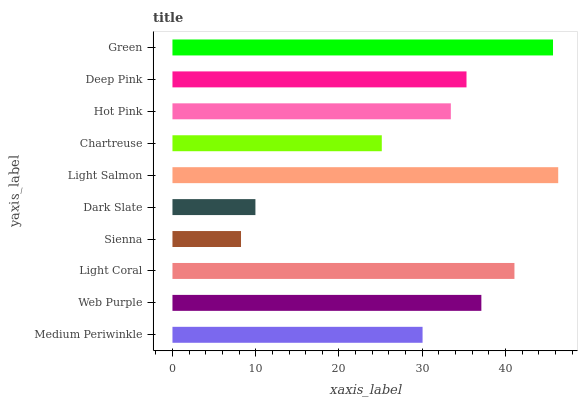Is Sienna the minimum?
Answer yes or no. Yes. Is Light Salmon the maximum?
Answer yes or no. Yes. Is Web Purple the minimum?
Answer yes or no. No. Is Web Purple the maximum?
Answer yes or no. No. Is Web Purple greater than Medium Periwinkle?
Answer yes or no. Yes. Is Medium Periwinkle less than Web Purple?
Answer yes or no. Yes. Is Medium Periwinkle greater than Web Purple?
Answer yes or no. No. Is Web Purple less than Medium Periwinkle?
Answer yes or no. No. Is Deep Pink the high median?
Answer yes or no. Yes. Is Hot Pink the low median?
Answer yes or no. Yes. Is Light Salmon the high median?
Answer yes or no. No. Is Chartreuse the low median?
Answer yes or no. No. 